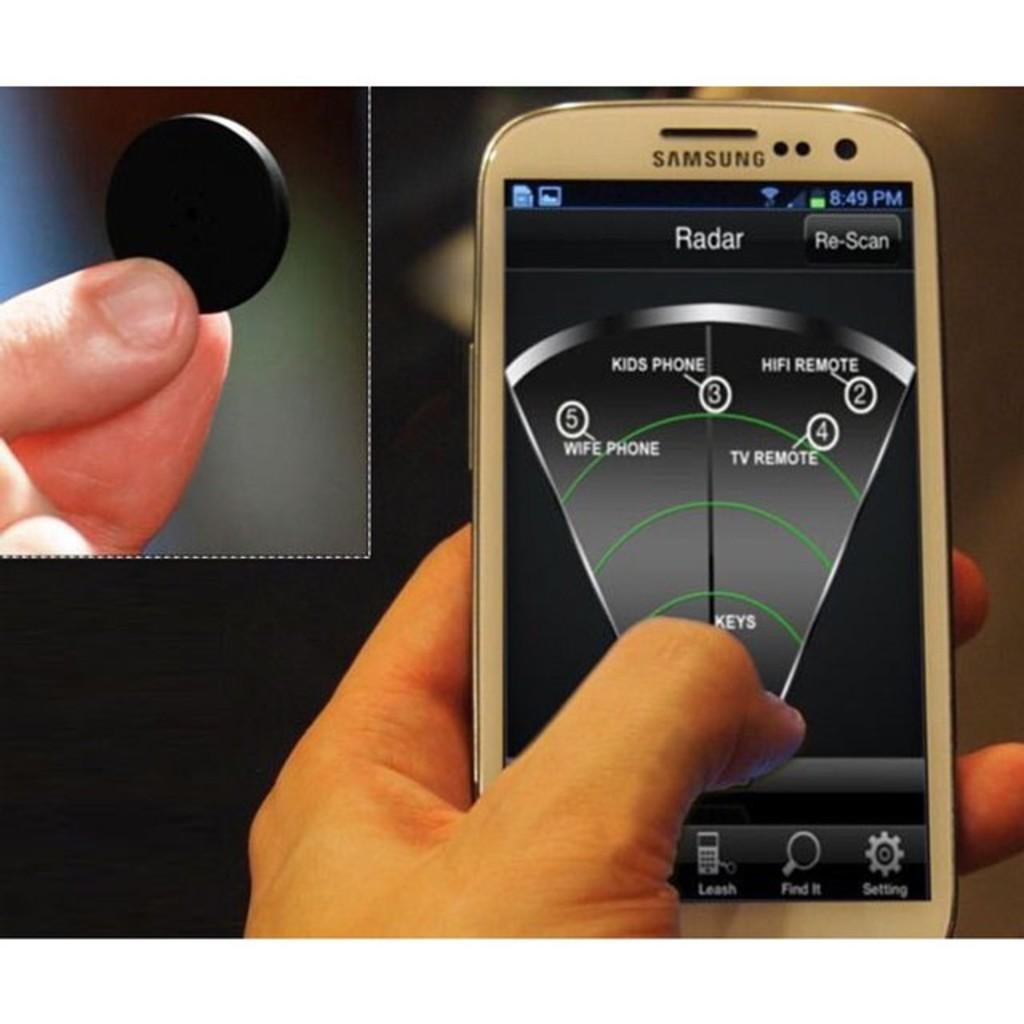What kind of app is this?
Your answer should be very brief. Radar. What is the time?
Your answer should be compact. 8:49. 